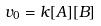Convert formula to latex. <formula><loc_0><loc_0><loc_500><loc_500>v _ { 0 } = k [ A ] [ B ]</formula> 